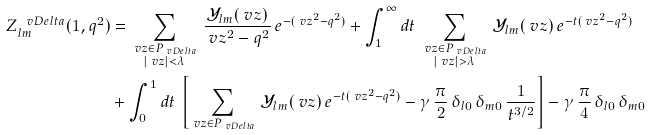Convert formula to latex. <formula><loc_0><loc_0><loc_500><loc_500>Z _ { l m } ^ { \ v D e l t a } ( 1 , q ^ { 2 } ) & = \sum _ { \substack { \ v z \in P _ { \ v D e l t a } \\ | \ v z | < \lambda } } \, \frac { \mathcal { Y } _ { l m } ( \ v z ) } { \ v z ^ { 2 } - q ^ { 2 } } \, e ^ { - ( \ v z ^ { 2 } - q ^ { 2 } ) } + \int _ { 1 } ^ { \infty } d t \, \sum _ { \substack { \ v z \in P _ { \ v D e l t a } \\ | \ v z | > \lambda } } \, \mathcal { Y } _ { l m } ( \ v z ) \, e ^ { - t ( \ v z ^ { 2 } - q ^ { 2 } ) } \\ & + \int _ { 0 } ^ { 1 } d t \, \left [ \sum _ { \ v z \in P _ { \ v D e l t a } } \, \mathcal { Y } _ { l m } ( \ v z ) \, e ^ { - t ( \ v z ^ { 2 } - q ^ { 2 } ) } - \gamma \, \frac { \pi } { 2 } \, \delta _ { l 0 } \, \delta _ { m 0 } \, \frac { 1 } { t ^ { 3 / 2 } } \right ] - \gamma \, \frac { \pi } { 4 } \, \delta _ { l 0 } \, \delta _ { m 0 }</formula> 